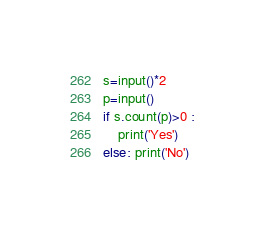Convert code to text. <code><loc_0><loc_0><loc_500><loc_500><_Python_>s=input()*2
p=input()
if s.count(p)>0 :
    print('Yes')
else: print('No')
</code> 